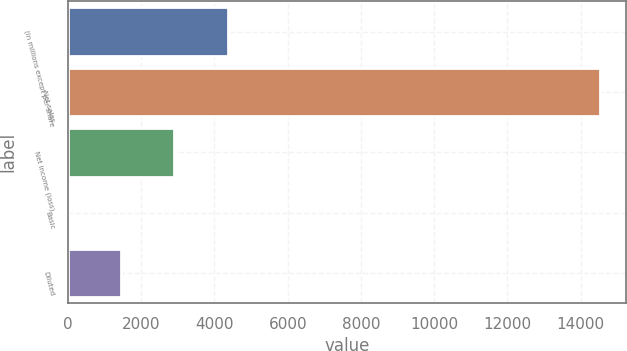Convert chart. <chart><loc_0><loc_0><loc_500><loc_500><bar_chart><fcel>(in millions except per share<fcel>Net sales<fcel>Net income (loss)<fcel>Basic<fcel>Diluted<nl><fcel>4356.26<fcel>14519.6<fcel>2904.35<fcel>0.53<fcel>1452.44<nl></chart> 